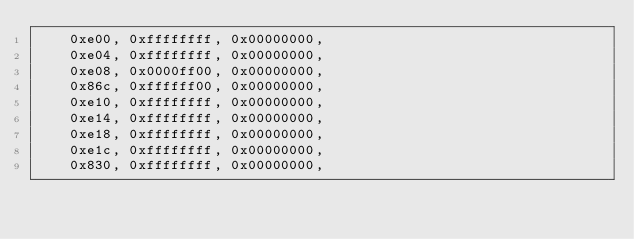Convert code to text. <code><loc_0><loc_0><loc_500><loc_500><_C_>	0xe00, 0xffffffff, 0x00000000,
	0xe04, 0xffffffff, 0x00000000,
	0xe08, 0x0000ff00, 0x00000000,
	0x86c, 0xffffff00, 0x00000000,
	0xe10, 0xffffffff, 0x00000000,
	0xe14, 0xffffffff, 0x00000000,
	0xe18, 0xffffffff, 0x00000000,
	0xe1c, 0xffffffff, 0x00000000,
	0x830, 0xffffffff, 0x00000000,</code> 